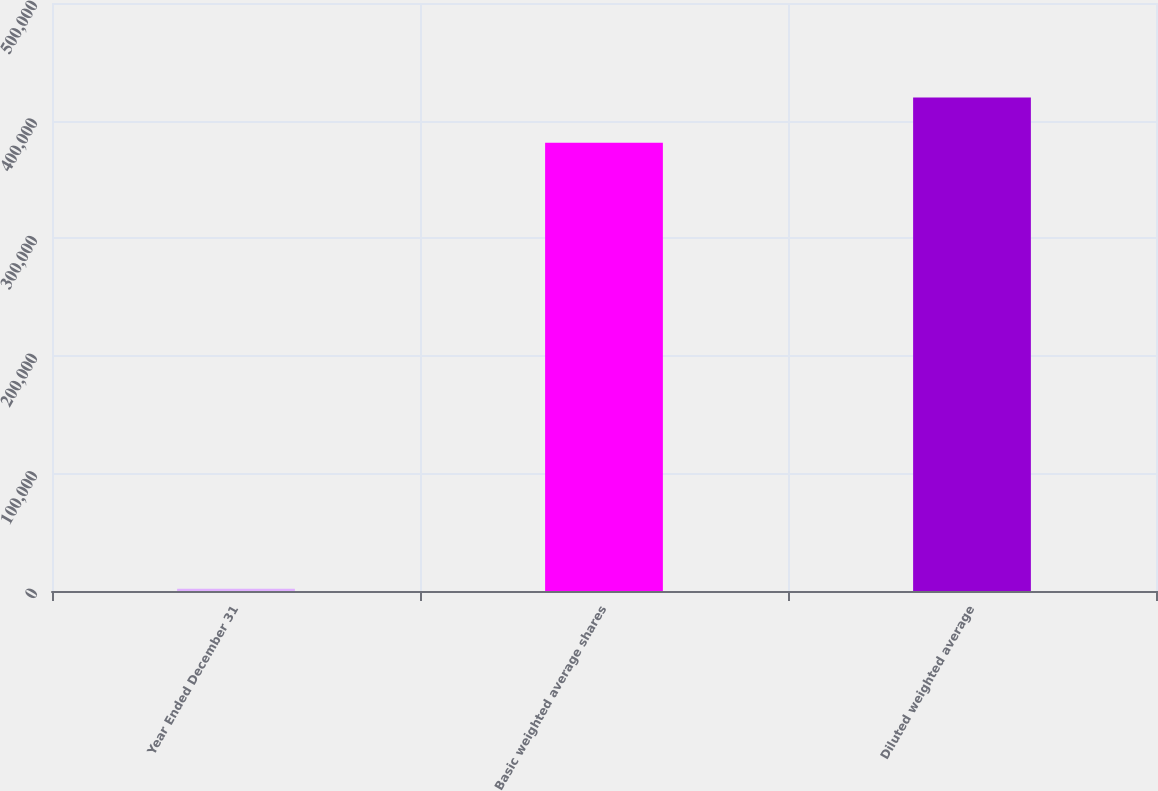Convert chart. <chart><loc_0><loc_0><loc_500><loc_500><bar_chart><fcel>Year Ended December 31<fcel>Basic weighted average shares<fcel>Diluted weighted average<nl><fcel>2010<fcel>381240<fcel>419563<nl></chart> 